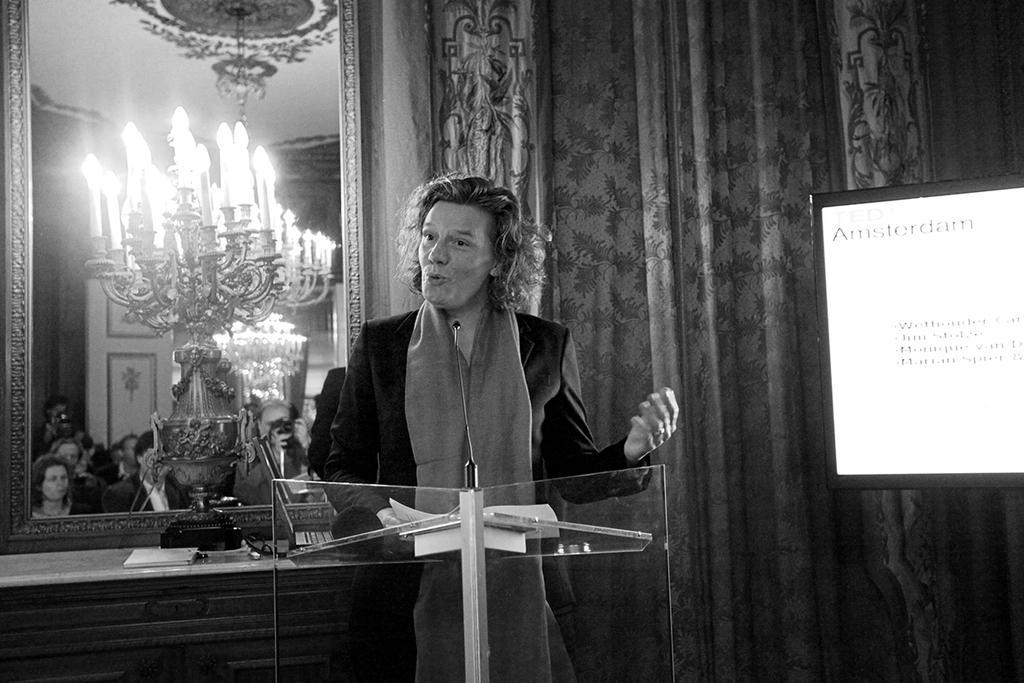Can you describe this image briefly? This is the black and white image and we can see a person standing and there is a podium in front of him and we can see some objects on it. There is a mirror with the reflections of some people and some other things and there is a table with some objects and we can see a screen with some text on the right side of the image. 